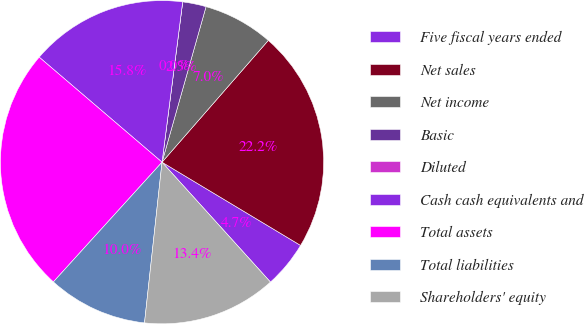Convert chart to OTSL. <chart><loc_0><loc_0><loc_500><loc_500><pie_chart><fcel>Five fiscal years ended<fcel>Net sales<fcel>Net income<fcel>Basic<fcel>Diluted<fcel>Cash cash equivalents and<fcel>Total assets<fcel>Total liabilities<fcel>Shareholders' equity<nl><fcel>4.69%<fcel>22.19%<fcel>7.03%<fcel>2.35%<fcel>0.0%<fcel>15.78%<fcel>24.53%<fcel>10.0%<fcel>13.43%<nl></chart> 